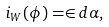Convert formula to latex. <formula><loc_0><loc_0><loc_500><loc_500>i _ { W } ( \phi ) = \in d \alpha ,</formula> 